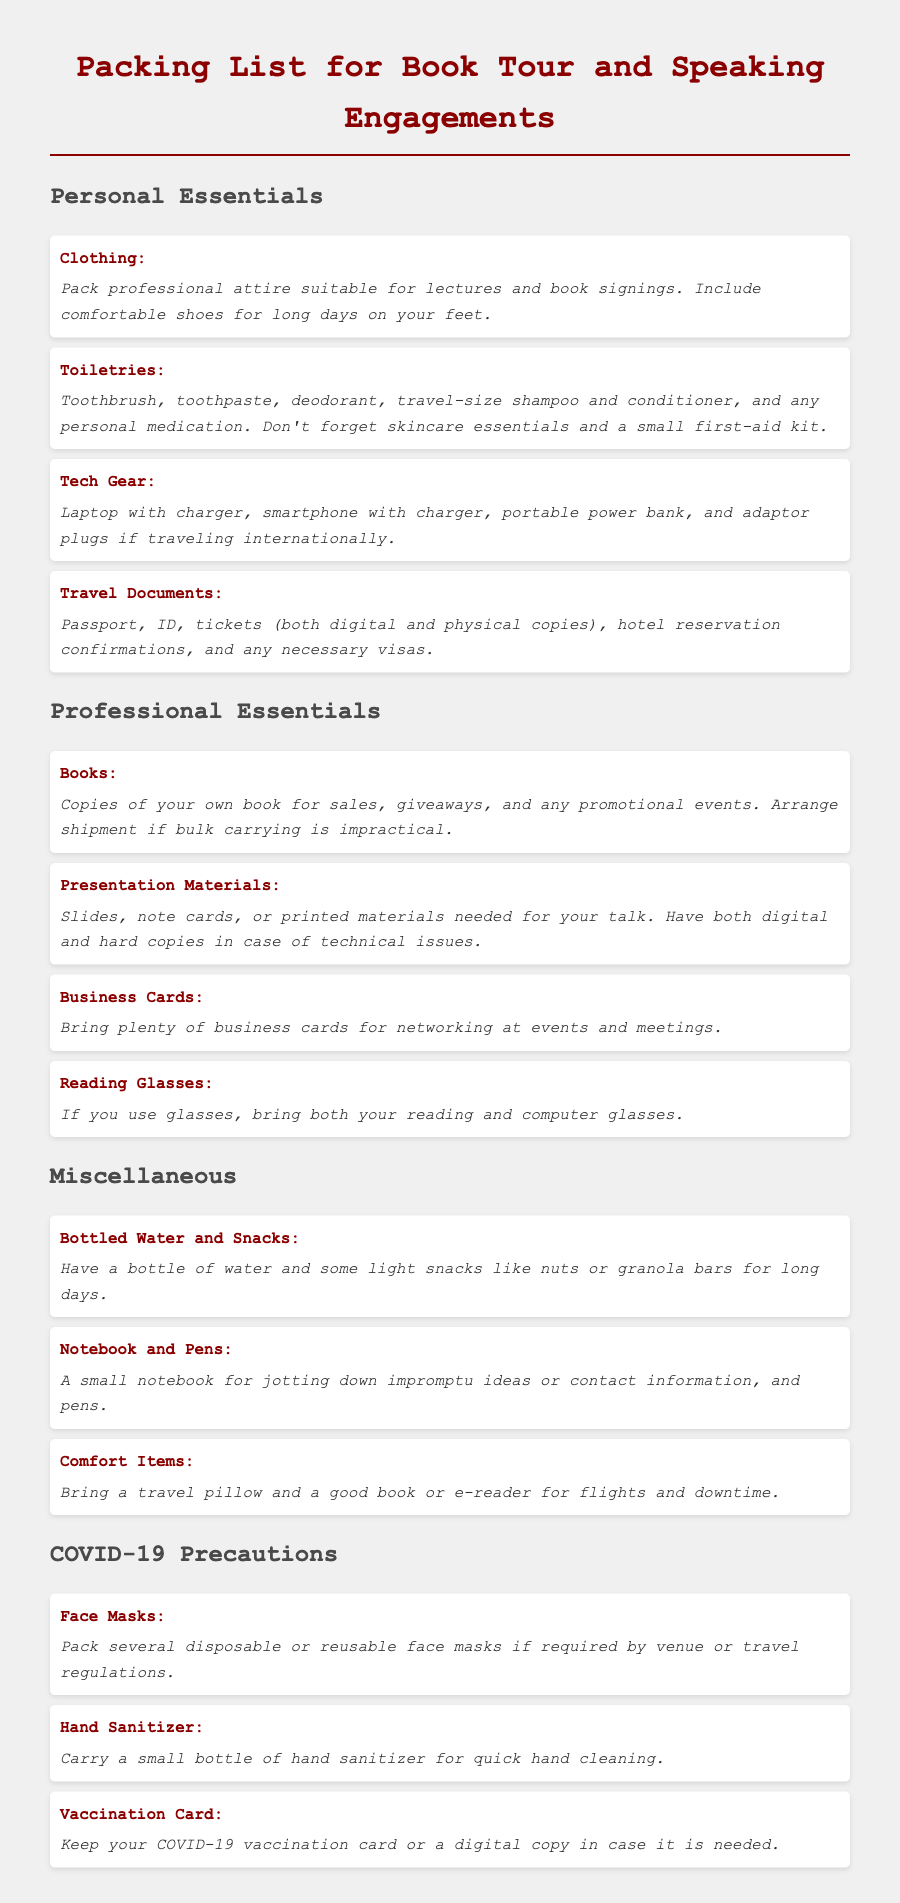What is the first item listed under Personal Essentials? The first item listed under Personal Essentials is "Clothing."
Answer: Clothing How many categories are there in the packing list? The packing list is divided into four categories: Personal Essentials, Professional Essentials, Miscellaneous, and COVID-19 Precautions.
Answer: Four What should you pack for COVID-19 precautions? The items for COVID-19 precautions include face masks, hand sanitizer, and a vaccination card.
Answer: Face masks, hand sanitizer, vaccination card What type of items should be included in Presentation Materials? Presentation Materials should include slides, note cards, or printed materials.
Answer: Slides, note cards, printed materials What is recommended for long days on your feet? Comfortable shoes are recommended for long days on your feet.
Answer: Comfortable shoes What should you bring in case bulk carrying of books is impractical? You should arrange shipment of books if bulk carrying is impractical.
Answer: Arrange shipment What does the packing list suggest for jotting down ideas? The packing list suggests bringing a small notebook for jotting down ideas.
Answer: A small notebook How many business cards should you bring? Bring plenty of business cards for networking at events.
Answer: Plenty What type of items are suggested for comfort during travel? Comfort items suggested include a travel pillow and a good book or e-reader.
Answer: Travel pillow, good book or e-reader 